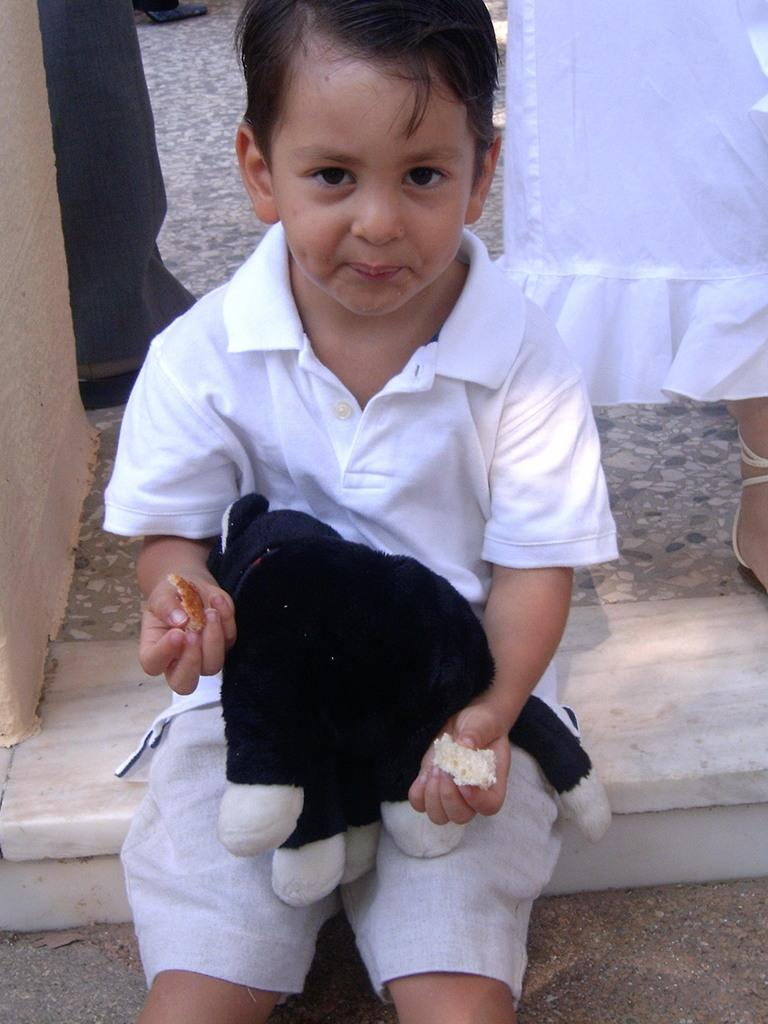What is the main subject of the image? The main subject of the image is a small boy. What is the boy doing in the image? The boy is sitting in the image. What object is the boy holding in his lap? The boy is holding a teddy bear in his lap. What else is the boy holding in his hand? The boy is holding food items in his hand. Can you describe the woman standing behind the boy? There is a woman standing behind the boy in the image. What type of stone is the boy using to create a painting in the image? There is no stone or painting present in the image; the boy is holding a teddy bear and food items. What kind of flame can be seen coming from the woman's hand in the image? There is no flame present in the image; the woman is standing behind the boy. 